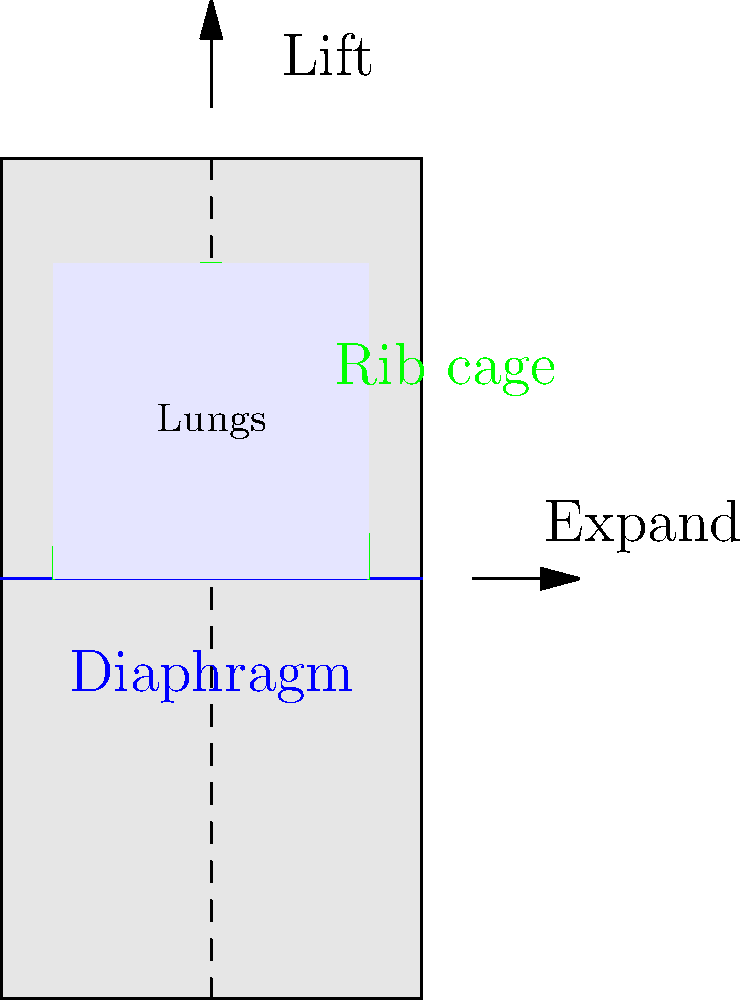In the diagram showing the side view of a human torso, which two biomechanical actions should a vocalist focus on to maximize breath support for optimal vocal performance? To maximize breath support for optimal vocal performance, vocalists should focus on two key biomechanical actions:

1. Diaphragmatic expansion:
   - The diaphragm, shown as a blue line in the diagram, should move downward and outward.
   - This action increases the volume of the thoracic cavity, creating negative pressure in the lungs.
   - The expansion is indicated by the horizontal arrow pointing outward.

2. Rib cage elevation:
   - The rib cage, outlined in green, should lift and expand.
   - This action further increases lung capacity by creating more space in the thoracic cavity.
   - The upward arrow at the top of the diagram illustrates this lifting motion.

These two actions work together to:
- Maximize lung capacity
- Increase air intake
- Provide better control over exhalation

By focusing on these biomechanical actions, vocalists can achieve:
- Improved breath support
- Enhanced vocal stamina
- Better control over dynamics and phrasing

As a mainstream music producer, understanding these principles can help in guiding vocalists to achieve industry-standard performance quality and consistency in the studio.
Answer: Diaphragmatic expansion and rib cage elevation 